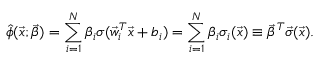<formula> <loc_0><loc_0><loc_500><loc_500>\hat { \phi } ( \vec { x } ; \vec { \beta } ) = \sum _ { i = 1 } ^ { N } \beta _ { i } \sigma ( \vec { w } _ { i } ^ { T } \vec { x } + b _ { i } ) = \sum _ { i = 1 } ^ { N } \beta _ { i } \sigma _ { i } ( \vec { x } ) \equiv \vec { \beta } ^ { T } \vec { \sigma } ( \vec { x } ) .</formula> 